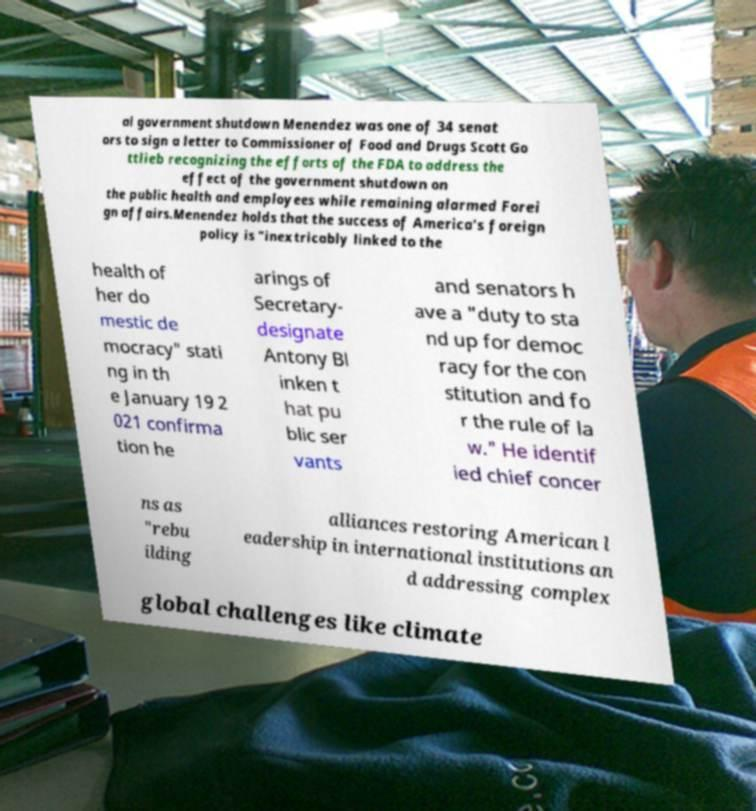Can you accurately transcribe the text from the provided image for me? al government shutdown Menendez was one of 34 senat ors to sign a letter to Commissioner of Food and Drugs Scott Go ttlieb recognizing the efforts of the FDA to address the effect of the government shutdown on the public health and employees while remaining alarmed Forei gn affairs.Menendez holds that the success of America's foreign policy is "inextricably linked to the health of her do mestic de mocracy" stati ng in th e January 19 2 021 confirma tion he arings of Secretary- designate Antony Bl inken t hat pu blic ser vants and senators h ave a "duty to sta nd up for democ racy for the con stitution and fo r the rule of la w." He identif ied chief concer ns as "rebu ilding alliances restoring American l eadership in international institutions an d addressing complex global challenges like climate 